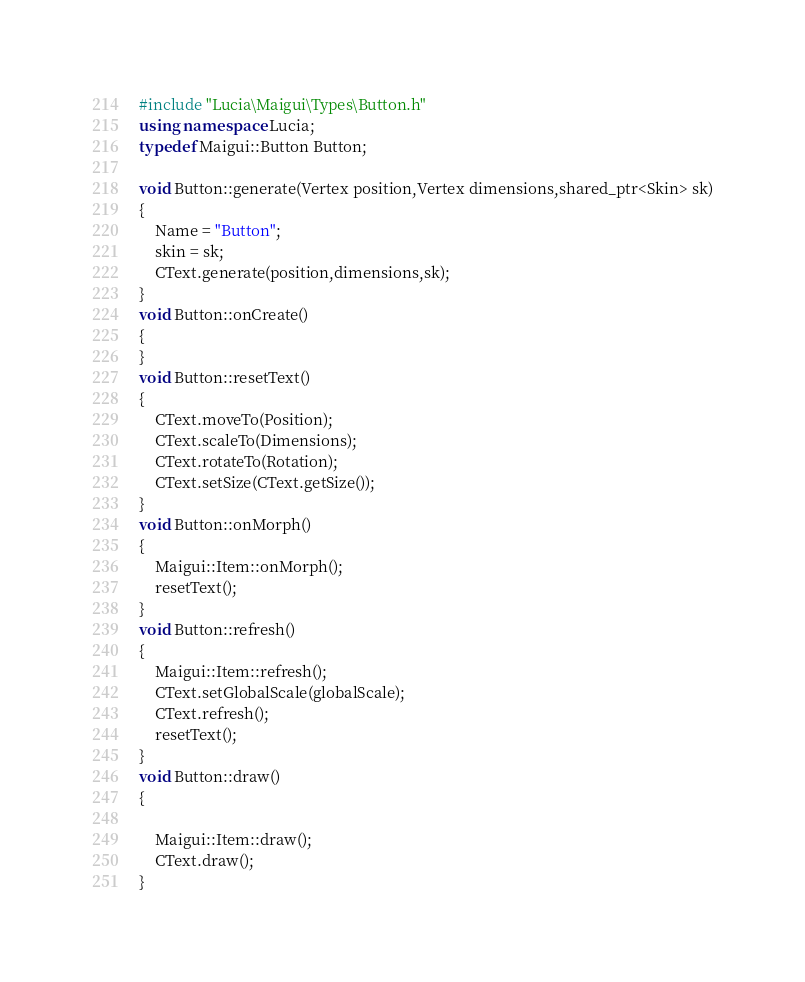<code> <loc_0><loc_0><loc_500><loc_500><_C++_>#include "Lucia\Maigui\Types\Button.h"
using namespace Lucia;
typedef Maigui::Button Button;

void Button::generate(Vertex position,Vertex dimensions,shared_ptr<Skin> sk)
{
    Name = "Button";
    skin = sk;
    CText.generate(position,dimensions,sk);
}
void Button::onCreate()
{
}
void Button::resetText()
{
    CText.moveTo(Position);
    CText.scaleTo(Dimensions);
    CText.rotateTo(Rotation);
    CText.setSize(CText.getSize());
}
void Button::onMorph()
{
    Maigui::Item::onMorph();
    resetText();
}
void Button::refresh()
{
    Maigui::Item::refresh();
    CText.setGlobalScale(globalScale);
    CText.refresh();
    resetText();
}
void Button::draw()
{
    
    Maigui::Item::draw();
    CText.draw();
}
</code> 